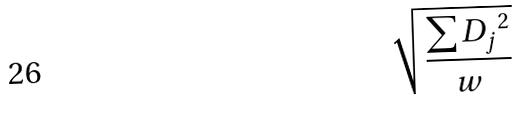Convert formula to latex. <formula><loc_0><loc_0><loc_500><loc_500>\sqrt { \frac { \sum { D _ { j } } ^ { 2 } } { w } }</formula> 